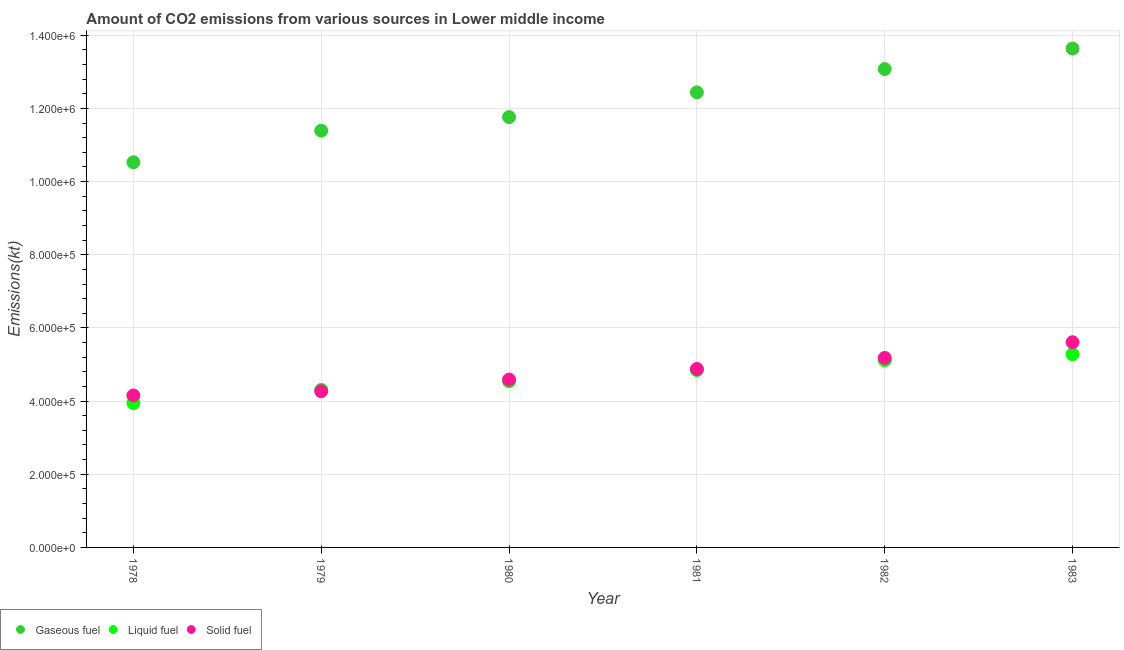What is the amount of co2 emissions from liquid fuel in 1979?
Your answer should be compact. 4.31e+05. Across all years, what is the maximum amount of co2 emissions from solid fuel?
Offer a very short reply. 5.61e+05. Across all years, what is the minimum amount of co2 emissions from solid fuel?
Provide a succinct answer. 4.15e+05. In which year was the amount of co2 emissions from liquid fuel maximum?
Offer a very short reply. 1983. In which year was the amount of co2 emissions from liquid fuel minimum?
Ensure brevity in your answer.  1978. What is the total amount of co2 emissions from liquid fuel in the graph?
Your answer should be very brief. 2.80e+06. What is the difference between the amount of co2 emissions from gaseous fuel in 1978 and that in 1983?
Provide a succinct answer. -3.11e+05. What is the difference between the amount of co2 emissions from gaseous fuel in 1981 and the amount of co2 emissions from solid fuel in 1983?
Your answer should be very brief. 6.83e+05. What is the average amount of co2 emissions from solid fuel per year?
Offer a very short reply. 4.78e+05. In the year 1978, what is the difference between the amount of co2 emissions from liquid fuel and amount of co2 emissions from gaseous fuel?
Your answer should be very brief. -6.58e+05. In how many years, is the amount of co2 emissions from liquid fuel greater than 960000 kt?
Provide a succinct answer. 0. What is the ratio of the amount of co2 emissions from solid fuel in 1979 to that in 1980?
Provide a short and direct response. 0.93. What is the difference between the highest and the second highest amount of co2 emissions from solid fuel?
Keep it short and to the point. 4.29e+04. What is the difference between the highest and the lowest amount of co2 emissions from gaseous fuel?
Offer a very short reply. 3.11e+05. Is the sum of the amount of co2 emissions from gaseous fuel in 1978 and 1982 greater than the maximum amount of co2 emissions from liquid fuel across all years?
Offer a very short reply. Yes. Is it the case that in every year, the sum of the amount of co2 emissions from gaseous fuel and amount of co2 emissions from liquid fuel is greater than the amount of co2 emissions from solid fuel?
Make the answer very short. Yes. Does the amount of co2 emissions from liquid fuel monotonically increase over the years?
Provide a succinct answer. Yes. Are the values on the major ticks of Y-axis written in scientific E-notation?
Your response must be concise. Yes. How are the legend labels stacked?
Your answer should be compact. Horizontal. What is the title of the graph?
Make the answer very short. Amount of CO2 emissions from various sources in Lower middle income. Does "Transport services" appear as one of the legend labels in the graph?
Offer a terse response. No. What is the label or title of the X-axis?
Provide a succinct answer. Year. What is the label or title of the Y-axis?
Your answer should be compact. Emissions(kt). What is the Emissions(kt) of Gaseous fuel in 1978?
Your answer should be very brief. 1.05e+06. What is the Emissions(kt) of Liquid fuel in 1978?
Your response must be concise. 3.94e+05. What is the Emissions(kt) of Solid fuel in 1978?
Your answer should be very brief. 4.15e+05. What is the Emissions(kt) of Gaseous fuel in 1979?
Your answer should be compact. 1.14e+06. What is the Emissions(kt) in Liquid fuel in 1979?
Give a very brief answer. 4.31e+05. What is the Emissions(kt) of Solid fuel in 1979?
Provide a short and direct response. 4.27e+05. What is the Emissions(kt) in Gaseous fuel in 1980?
Give a very brief answer. 1.18e+06. What is the Emissions(kt) in Liquid fuel in 1980?
Offer a very short reply. 4.54e+05. What is the Emissions(kt) of Solid fuel in 1980?
Offer a terse response. 4.59e+05. What is the Emissions(kt) in Gaseous fuel in 1981?
Ensure brevity in your answer.  1.24e+06. What is the Emissions(kt) of Liquid fuel in 1981?
Provide a succinct answer. 4.85e+05. What is the Emissions(kt) in Solid fuel in 1981?
Your answer should be very brief. 4.88e+05. What is the Emissions(kt) of Gaseous fuel in 1982?
Offer a very short reply. 1.31e+06. What is the Emissions(kt) in Liquid fuel in 1982?
Make the answer very short. 5.12e+05. What is the Emissions(kt) in Solid fuel in 1982?
Provide a succinct answer. 5.18e+05. What is the Emissions(kt) of Gaseous fuel in 1983?
Your answer should be very brief. 1.36e+06. What is the Emissions(kt) of Liquid fuel in 1983?
Offer a terse response. 5.28e+05. What is the Emissions(kt) of Solid fuel in 1983?
Make the answer very short. 5.61e+05. Across all years, what is the maximum Emissions(kt) in Gaseous fuel?
Keep it short and to the point. 1.36e+06. Across all years, what is the maximum Emissions(kt) of Liquid fuel?
Offer a very short reply. 5.28e+05. Across all years, what is the maximum Emissions(kt) of Solid fuel?
Your answer should be very brief. 5.61e+05. Across all years, what is the minimum Emissions(kt) of Gaseous fuel?
Keep it short and to the point. 1.05e+06. Across all years, what is the minimum Emissions(kt) of Liquid fuel?
Make the answer very short. 3.94e+05. Across all years, what is the minimum Emissions(kt) of Solid fuel?
Give a very brief answer. 4.15e+05. What is the total Emissions(kt) of Gaseous fuel in the graph?
Give a very brief answer. 7.28e+06. What is the total Emissions(kt) of Liquid fuel in the graph?
Offer a very short reply. 2.80e+06. What is the total Emissions(kt) of Solid fuel in the graph?
Provide a succinct answer. 2.87e+06. What is the difference between the Emissions(kt) of Gaseous fuel in 1978 and that in 1979?
Your response must be concise. -8.64e+04. What is the difference between the Emissions(kt) of Liquid fuel in 1978 and that in 1979?
Provide a succinct answer. -3.61e+04. What is the difference between the Emissions(kt) of Solid fuel in 1978 and that in 1979?
Ensure brevity in your answer.  -1.14e+04. What is the difference between the Emissions(kt) of Gaseous fuel in 1978 and that in 1980?
Keep it short and to the point. -1.24e+05. What is the difference between the Emissions(kt) in Liquid fuel in 1978 and that in 1980?
Ensure brevity in your answer.  -5.97e+04. What is the difference between the Emissions(kt) of Solid fuel in 1978 and that in 1980?
Your answer should be very brief. -4.34e+04. What is the difference between the Emissions(kt) of Gaseous fuel in 1978 and that in 1981?
Provide a succinct answer. -1.91e+05. What is the difference between the Emissions(kt) in Liquid fuel in 1978 and that in 1981?
Provide a succinct answer. -9.03e+04. What is the difference between the Emissions(kt) of Solid fuel in 1978 and that in 1981?
Give a very brief answer. -7.23e+04. What is the difference between the Emissions(kt) of Gaseous fuel in 1978 and that in 1982?
Keep it short and to the point. -2.55e+05. What is the difference between the Emissions(kt) of Liquid fuel in 1978 and that in 1982?
Your answer should be very brief. -1.17e+05. What is the difference between the Emissions(kt) in Solid fuel in 1978 and that in 1982?
Offer a terse response. -1.03e+05. What is the difference between the Emissions(kt) in Gaseous fuel in 1978 and that in 1983?
Offer a terse response. -3.11e+05. What is the difference between the Emissions(kt) in Liquid fuel in 1978 and that in 1983?
Your answer should be very brief. -1.34e+05. What is the difference between the Emissions(kt) in Solid fuel in 1978 and that in 1983?
Give a very brief answer. -1.46e+05. What is the difference between the Emissions(kt) of Gaseous fuel in 1979 and that in 1980?
Make the answer very short. -3.71e+04. What is the difference between the Emissions(kt) in Liquid fuel in 1979 and that in 1980?
Keep it short and to the point. -2.37e+04. What is the difference between the Emissions(kt) of Solid fuel in 1979 and that in 1980?
Keep it short and to the point. -3.20e+04. What is the difference between the Emissions(kt) in Gaseous fuel in 1979 and that in 1981?
Give a very brief answer. -1.05e+05. What is the difference between the Emissions(kt) in Liquid fuel in 1979 and that in 1981?
Offer a very short reply. -5.42e+04. What is the difference between the Emissions(kt) of Solid fuel in 1979 and that in 1981?
Your answer should be compact. -6.09e+04. What is the difference between the Emissions(kt) of Gaseous fuel in 1979 and that in 1982?
Your response must be concise. -1.68e+05. What is the difference between the Emissions(kt) in Liquid fuel in 1979 and that in 1982?
Offer a terse response. -8.13e+04. What is the difference between the Emissions(kt) in Solid fuel in 1979 and that in 1982?
Your answer should be compact. -9.12e+04. What is the difference between the Emissions(kt) in Gaseous fuel in 1979 and that in 1983?
Keep it short and to the point. -2.25e+05. What is the difference between the Emissions(kt) of Liquid fuel in 1979 and that in 1983?
Your answer should be very brief. -9.77e+04. What is the difference between the Emissions(kt) of Solid fuel in 1979 and that in 1983?
Offer a terse response. -1.34e+05. What is the difference between the Emissions(kt) in Gaseous fuel in 1980 and that in 1981?
Offer a very short reply. -6.76e+04. What is the difference between the Emissions(kt) of Liquid fuel in 1980 and that in 1981?
Ensure brevity in your answer.  -3.05e+04. What is the difference between the Emissions(kt) of Solid fuel in 1980 and that in 1981?
Ensure brevity in your answer.  -2.89e+04. What is the difference between the Emissions(kt) in Gaseous fuel in 1980 and that in 1982?
Offer a terse response. -1.31e+05. What is the difference between the Emissions(kt) in Liquid fuel in 1980 and that in 1982?
Ensure brevity in your answer.  -5.76e+04. What is the difference between the Emissions(kt) in Solid fuel in 1980 and that in 1982?
Provide a short and direct response. -5.92e+04. What is the difference between the Emissions(kt) in Gaseous fuel in 1980 and that in 1983?
Give a very brief answer. -1.87e+05. What is the difference between the Emissions(kt) in Liquid fuel in 1980 and that in 1983?
Your response must be concise. -7.40e+04. What is the difference between the Emissions(kt) in Solid fuel in 1980 and that in 1983?
Offer a very short reply. -1.02e+05. What is the difference between the Emissions(kt) of Gaseous fuel in 1981 and that in 1982?
Make the answer very short. -6.37e+04. What is the difference between the Emissions(kt) of Liquid fuel in 1981 and that in 1982?
Your answer should be very brief. -2.70e+04. What is the difference between the Emissions(kt) in Solid fuel in 1981 and that in 1982?
Your answer should be compact. -3.03e+04. What is the difference between the Emissions(kt) in Gaseous fuel in 1981 and that in 1983?
Your answer should be compact. -1.20e+05. What is the difference between the Emissions(kt) of Liquid fuel in 1981 and that in 1983?
Make the answer very short. -4.35e+04. What is the difference between the Emissions(kt) in Solid fuel in 1981 and that in 1983?
Keep it short and to the point. -7.32e+04. What is the difference between the Emissions(kt) of Gaseous fuel in 1982 and that in 1983?
Ensure brevity in your answer.  -5.61e+04. What is the difference between the Emissions(kt) of Liquid fuel in 1982 and that in 1983?
Make the answer very short. -1.64e+04. What is the difference between the Emissions(kt) of Solid fuel in 1982 and that in 1983?
Make the answer very short. -4.29e+04. What is the difference between the Emissions(kt) in Gaseous fuel in 1978 and the Emissions(kt) in Liquid fuel in 1979?
Your response must be concise. 6.22e+05. What is the difference between the Emissions(kt) in Gaseous fuel in 1978 and the Emissions(kt) in Solid fuel in 1979?
Give a very brief answer. 6.26e+05. What is the difference between the Emissions(kt) of Liquid fuel in 1978 and the Emissions(kt) of Solid fuel in 1979?
Ensure brevity in your answer.  -3.24e+04. What is the difference between the Emissions(kt) of Gaseous fuel in 1978 and the Emissions(kt) of Liquid fuel in 1980?
Your response must be concise. 5.99e+05. What is the difference between the Emissions(kt) of Gaseous fuel in 1978 and the Emissions(kt) of Solid fuel in 1980?
Offer a terse response. 5.94e+05. What is the difference between the Emissions(kt) of Liquid fuel in 1978 and the Emissions(kt) of Solid fuel in 1980?
Provide a short and direct response. -6.44e+04. What is the difference between the Emissions(kt) of Gaseous fuel in 1978 and the Emissions(kt) of Liquid fuel in 1981?
Offer a terse response. 5.68e+05. What is the difference between the Emissions(kt) of Gaseous fuel in 1978 and the Emissions(kt) of Solid fuel in 1981?
Provide a succinct answer. 5.65e+05. What is the difference between the Emissions(kt) in Liquid fuel in 1978 and the Emissions(kt) in Solid fuel in 1981?
Make the answer very short. -9.33e+04. What is the difference between the Emissions(kt) in Gaseous fuel in 1978 and the Emissions(kt) in Liquid fuel in 1982?
Ensure brevity in your answer.  5.41e+05. What is the difference between the Emissions(kt) in Gaseous fuel in 1978 and the Emissions(kt) in Solid fuel in 1982?
Give a very brief answer. 5.35e+05. What is the difference between the Emissions(kt) of Liquid fuel in 1978 and the Emissions(kt) of Solid fuel in 1982?
Your response must be concise. -1.24e+05. What is the difference between the Emissions(kt) in Gaseous fuel in 1978 and the Emissions(kt) in Liquid fuel in 1983?
Your answer should be compact. 5.25e+05. What is the difference between the Emissions(kt) in Gaseous fuel in 1978 and the Emissions(kt) in Solid fuel in 1983?
Your answer should be very brief. 4.92e+05. What is the difference between the Emissions(kt) in Liquid fuel in 1978 and the Emissions(kt) in Solid fuel in 1983?
Provide a succinct answer. -1.66e+05. What is the difference between the Emissions(kt) in Gaseous fuel in 1979 and the Emissions(kt) in Liquid fuel in 1980?
Ensure brevity in your answer.  6.85e+05. What is the difference between the Emissions(kt) in Gaseous fuel in 1979 and the Emissions(kt) in Solid fuel in 1980?
Your response must be concise. 6.80e+05. What is the difference between the Emissions(kt) in Liquid fuel in 1979 and the Emissions(kt) in Solid fuel in 1980?
Ensure brevity in your answer.  -2.83e+04. What is the difference between the Emissions(kt) of Gaseous fuel in 1979 and the Emissions(kt) of Liquid fuel in 1981?
Your answer should be compact. 6.54e+05. What is the difference between the Emissions(kt) in Gaseous fuel in 1979 and the Emissions(kt) in Solid fuel in 1981?
Your response must be concise. 6.51e+05. What is the difference between the Emissions(kt) in Liquid fuel in 1979 and the Emissions(kt) in Solid fuel in 1981?
Ensure brevity in your answer.  -5.72e+04. What is the difference between the Emissions(kt) in Gaseous fuel in 1979 and the Emissions(kt) in Liquid fuel in 1982?
Give a very brief answer. 6.27e+05. What is the difference between the Emissions(kt) in Gaseous fuel in 1979 and the Emissions(kt) in Solid fuel in 1982?
Provide a succinct answer. 6.21e+05. What is the difference between the Emissions(kt) of Liquid fuel in 1979 and the Emissions(kt) of Solid fuel in 1982?
Keep it short and to the point. -8.75e+04. What is the difference between the Emissions(kt) in Gaseous fuel in 1979 and the Emissions(kt) in Liquid fuel in 1983?
Your answer should be compact. 6.11e+05. What is the difference between the Emissions(kt) in Gaseous fuel in 1979 and the Emissions(kt) in Solid fuel in 1983?
Provide a short and direct response. 5.78e+05. What is the difference between the Emissions(kt) in Liquid fuel in 1979 and the Emissions(kt) in Solid fuel in 1983?
Provide a short and direct response. -1.30e+05. What is the difference between the Emissions(kt) of Gaseous fuel in 1980 and the Emissions(kt) of Liquid fuel in 1981?
Your response must be concise. 6.92e+05. What is the difference between the Emissions(kt) of Gaseous fuel in 1980 and the Emissions(kt) of Solid fuel in 1981?
Offer a terse response. 6.89e+05. What is the difference between the Emissions(kt) of Liquid fuel in 1980 and the Emissions(kt) of Solid fuel in 1981?
Provide a succinct answer. -3.35e+04. What is the difference between the Emissions(kt) in Gaseous fuel in 1980 and the Emissions(kt) in Liquid fuel in 1982?
Ensure brevity in your answer.  6.65e+05. What is the difference between the Emissions(kt) of Gaseous fuel in 1980 and the Emissions(kt) of Solid fuel in 1982?
Your answer should be very brief. 6.58e+05. What is the difference between the Emissions(kt) of Liquid fuel in 1980 and the Emissions(kt) of Solid fuel in 1982?
Provide a succinct answer. -6.38e+04. What is the difference between the Emissions(kt) of Gaseous fuel in 1980 and the Emissions(kt) of Liquid fuel in 1983?
Provide a short and direct response. 6.48e+05. What is the difference between the Emissions(kt) in Gaseous fuel in 1980 and the Emissions(kt) in Solid fuel in 1983?
Your answer should be compact. 6.15e+05. What is the difference between the Emissions(kt) in Liquid fuel in 1980 and the Emissions(kt) in Solid fuel in 1983?
Keep it short and to the point. -1.07e+05. What is the difference between the Emissions(kt) of Gaseous fuel in 1981 and the Emissions(kt) of Liquid fuel in 1982?
Make the answer very short. 7.32e+05. What is the difference between the Emissions(kt) of Gaseous fuel in 1981 and the Emissions(kt) of Solid fuel in 1982?
Offer a terse response. 7.26e+05. What is the difference between the Emissions(kt) in Liquid fuel in 1981 and the Emissions(kt) in Solid fuel in 1982?
Offer a terse response. -3.33e+04. What is the difference between the Emissions(kt) of Gaseous fuel in 1981 and the Emissions(kt) of Liquid fuel in 1983?
Keep it short and to the point. 7.16e+05. What is the difference between the Emissions(kt) of Gaseous fuel in 1981 and the Emissions(kt) of Solid fuel in 1983?
Your response must be concise. 6.83e+05. What is the difference between the Emissions(kt) of Liquid fuel in 1981 and the Emissions(kt) of Solid fuel in 1983?
Offer a terse response. -7.62e+04. What is the difference between the Emissions(kt) in Gaseous fuel in 1982 and the Emissions(kt) in Liquid fuel in 1983?
Provide a short and direct response. 7.79e+05. What is the difference between the Emissions(kt) in Gaseous fuel in 1982 and the Emissions(kt) in Solid fuel in 1983?
Keep it short and to the point. 7.47e+05. What is the difference between the Emissions(kt) of Liquid fuel in 1982 and the Emissions(kt) of Solid fuel in 1983?
Keep it short and to the point. -4.92e+04. What is the average Emissions(kt) in Gaseous fuel per year?
Your answer should be compact. 1.21e+06. What is the average Emissions(kt) of Liquid fuel per year?
Your answer should be very brief. 4.67e+05. What is the average Emissions(kt) of Solid fuel per year?
Your answer should be compact. 4.78e+05. In the year 1978, what is the difference between the Emissions(kt) of Gaseous fuel and Emissions(kt) of Liquid fuel?
Your answer should be very brief. 6.58e+05. In the year 1978, what is the difference between the Emissions(kt) of Gaseous fuel and Emissions(kt) of Solid fuel?
Provide a succinct answer. 6.37e+05. In the year 1978, what is the difference between the Emissions(kt) of Liquid fuel and Emissions(kt) of Solid fuel?
Make the answer very short. -2.10e+04. In the year 1979, what is the difference between the Emissions(kt) of Gaseous fuel and Emissions(kt) of Liquid fuel?
Your answer should be compact. 7.09e+05. In the year 1979, what is the difference between the Emissions(kt) in Gaseous fuel and Emissions(kt) in Solid fuel?
Offer a very short reply. 7.12e+05. In the year 1979, what is the difference between the Emissions(kt) in Liquid fuel and Emissions(kt) in Solid fuel?
Make the answer very short. 3683.37. In the year 1980, what is the difference between the Emissions(kt) in Gaseous fuel and Emissions(kt) in Liquid fuel?
Offer a very short reply. 7.22e+05. In the year 1980, what is the difference between the Emissions(kt) of Gaseous fuel and Emissions(kt) of Solid fuel?
Provide a short and direct response. 7.17e+05. In the year 1980, what is the difference between the Emissions(kt) in Liquid fuel and Emissions(kt) in Solid fuel?
Offer a terse response. -4662.59. In the year 1981, what is the difference between the Emissions(kt) of Gaseous fuel and Emissions(kt) of Liquid fuel?
Make the answer very short. 7.59e+05. In the year 1981, what is the difference between the Emissions(kt) of Gaseous fuel and Emissions(kt) of Solid fuel?
Your answer should be very brief. 7.56e+05. In the year 1981, what is the difference between the Emissions(kt) of Liquid fuel and Emissions(kt) of Solid fuel?
Offer a very short reply. -2986.55. In the year 1982, what is the difference between the Emissions(kt) in Gaseous fuel and Emissions(kt) in Liquid fuel?
Offer a very short reply. 7.96e+05. In the year 1982, what is the difference between the Emissions(kt) of Gaseous fuel and Emissions(kt) of Solid fuel?
Your answer should be compact. 7.90e+05. In the year 1982, what is the difference between the Emissions(kt) in Liquid fuel and Emissions(kt) in Solid fuel?
Offer a terse response. -6233.15. In the year 1983, what is the difference between the Emissions(kt) of Gaseous fuel and Emissions(kt) of Liquid fuel?
Provide a short and direct response. 8.36e+05. In the year 1983, what is the difference between the Emissions(kt) in Gaseous fuel and Emissions(kt) in Solid fuel?
Offer a terse response. 8.03e+05. In the year 1983, what is the difference between the Emissions(kt) in Liquid fuel and Emissions(kt) in Solid fuel?
Your answer should be very brief. -3.28e+04. What is the ratio of the Emissions(kt) of Gaseous fuel in 1978 to that in 1979?
Make the answer very short. 0.92. What is the ratio of the Emissions(kt) of Liquid fuel in 1978 to that in 1979?
Provide a short and direct response. 0.92. What is the ratio of the Emissions(kt) of Solid fuel in 1978 to that in 1979?
Provide a short and direct response. 0.97. What is the ratio of the Emissions(kt) of Gaseous fuel in 1978 to that in 1980?
Your response must be concise. 0.9. What is the ratio of the Emissions(kt) of Liquid fuel in 1978 to that in 1980?
Keep it short and to the point. 0.87. What is the ratio of the Emissions(kt) of Solid fuel in 1978 to that in 1980?
Ensure brevity in your answer.  0.91. What is the ratio of the Emissions(kt) in Gaseous fuel in 1978 to that in 1981?
Give a very brief answer. 0.85. What is the ratio of the Emissions(kt) of Liquid fuel in 1978 to that in 1981?
Offer a terse response. 0.81. What is the ratio of the Emissions(kt) of Solid fuel in 1978 to that in 1981?
Ensure brevity in your answer.  0.85. What is the ratio of the Emissions(kt) of Gaseous fuel in 1978 to that in 1982?
Your response must be concise. 0.81. What is the ratio of the Emissions(kt) in Liquid fuel in 1978 to that in 1982?
Ensure brevity in your answer.  0.77. What is the ratio of the Emissions(kt) in Solid fuel in 1978 to that in 1982?
Provide a succinct answer. 0.8. What is the ratio of the Emissions(kt) in Gaseous fuel in 1978 to that in 1983?
Ensure brevity in your answer.  0.77. What is the ratio of the Emissions(kt) in Liquid fuel in 1978 to that in 1983?
Keep it short and to the point. 0.75. What is the ratio of the Emissions(kt) of Solid fuel in 1978 to that in 1983?
Your answer should be compact. 0.74. What is the ratio of the Emissions(kt) in Gaseous fuel in 1979 to that in 1980?
Your answer should be compact. 0.97. What is the ratio of the Emissions(kt) of Liquid fuel in 1979 to that in 1980?
Your response must be concise. 0.95. What is the ratio of the Emissions(kt) of Solid fuel in 1979 to that in 1980?
Offer a very short reply. 0.93. What is the ratio of the Emissions(kt) of Gaseous fuel in 1979 to that in 1981?
Your response must be concise. 0.92. What is the ratio of the Emissions(kt) in Liquid fuel in 1979 to that in 1981?
Give a very brief answer. 0.89. What is the ratio of the Emissions(kt) of Solid fuel in 1979 to that in 1981?
Provide a short and direct response. 0.88. What is the ratio of the Emissions(kt) of Gaseous fuel in 1979 to that in 1982?
Offer a terse response. 0.87. What is the ratio of the Emissions(kt) of Liquid fuel in 1979 to that in 1982?
Your answer should be compact. 0.84. What is the ratio of the Emissions(kt) in Solid fuel in 1979 to that in 1982?
Your response must be concise. 0.82. What is the ratio of the Emissions(kt) in Gaseous fuel in 1979 to that in 1983?
Offer a terse response. 0.84. What is the ratio of the Emissions(kt) in Liquid fuel in 1979 to that in 1983?
Give a very brief answer. 0.82. What is the ratio of the Emissions(kt) of Solid fuel in 1979 to that in 1983?
Offer a terse response. 0.76. What is the ratio of the Emissions(kt) of Gaseous fuel in 1980 to that in 1981?
Provide a succinct answer. 0.95. What is the ratio of the Emissions(kt) in Liquid fuel in 1980 to that in 1981?
Offer a very short reply. 0.94. What is the ratio of the Emissions(kt) in Solid fuel in 1980 to that in 1981?
Offer a very short reply. 0.94. What is the ratio of the Emissions(kt) of Gaseous fuel in 1980 to that in 1982?
Provide a succinct answer. 0.9. What is the ratio of the Emissions(kt) of Liquid fuel in 1980 to that in 1982?
Your answer should be compact. 0.89. What is the ratio of the Emissions(kt) of Solid fuel in 1980 to that in 1982?
Offer a terse response. 0.89. What is the ratio of the Emissions(kt) of Gaseous fuel in 1980 to that in 1983?
Give a very brief answer. 0.86. What is the ratio of the Emissions(kt) in Liquid fuel in 1980 to that in 1983?
Offer a very short reply. 0.86. What is the ratio of the Emissions(kt) in Solid fuel in 1980 to that in 1983?
Your response must be concise. 0.82. What is the ratio of the Emissions(kt) in Gaseous fuel in 1981 to that in 1982?
Give a very brief answer. 0.95. What is the ratio of the Emissions(kt) of Liquid fuel in 1981 to that in 1982?
Provide a short and direct response. 0.95. What is the ratio of the Emissions(kt) of Solid fuel in 1981 to that in 1982?
Offer a terse response. 0.94. What is the ratio of the Emissions(kt) in Gaseous fuel in 1981 to that in 1983?
Your answer should be very brief. 0.91. What is the ratio of the Emissions(kt) in Liquid fuel in 1981 to that in 1983?
Offer a terse response. 0.92. What is the ratio of the Emissions(kt) in Solid fuel in 1981 to that in 1983?
Provide a short and direct response. 0.87. What is the ratio of the Emissions(kt) in Gaseous fuel in 1982 to that in 1983?
Ensure brevity in your answer.  0.96. What is the ratio of the Emissions(kt) in Liquid fuel in 1982 to that in 1983?
Offer a terse response. 0.97. What is the ratio of the Emissions(kt) of Solid fuel in 1982 to that in 1983?
Ensure brevity in your answer.  0.92. What is the difference between the highest and the second highest Emissions(kt) of Gaseous fuel?
Ensure brevity in your answer.  5.61e+04. What is the difference between the highest and the second highest Emissions(kt) in Liquid fuel?
Offer a terse response. 1.64e+04. What is the difference between the highest and the second highest Emissions(kt) of Solid fuel?
Keep it short and to the point. 4.29e+04. What is the difference between the highest and the lowest Emissions(kt) of Gaseous fuel?
Keep it short and to the point. 3.11e+05. What is the difference between the highest and the lowest Emissions(kt) of Liquid fuel?
Provide a succinct answer. 1.34e+05. What is the difference between the highest and the lowest Emissions(kt) in Solid fuel?
Your response must be concise. 1.46e+05. 